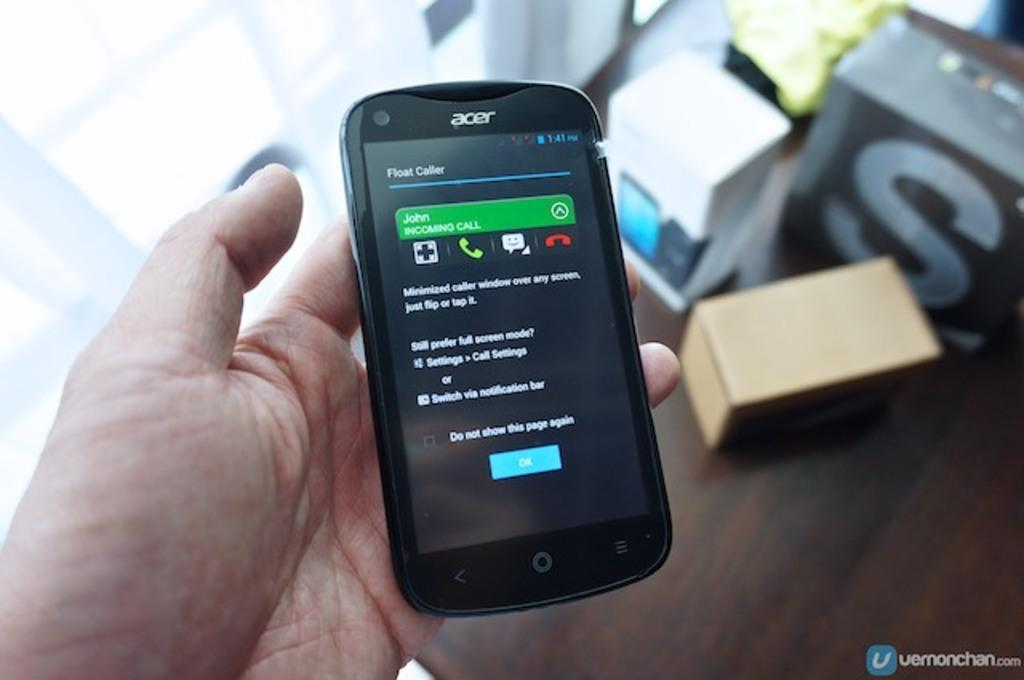<image>
Describe the image concisely. John is calling the owner of this Acer phone. 